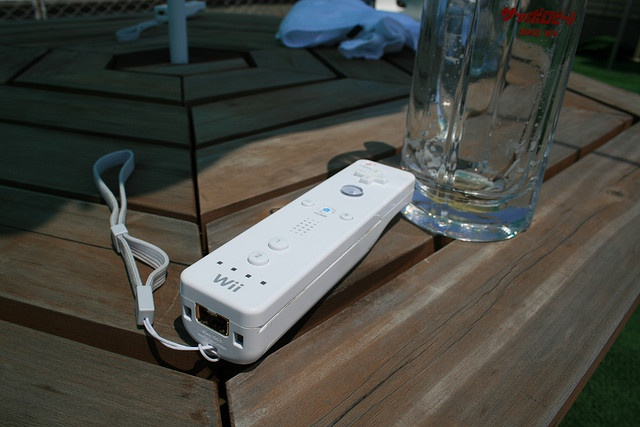Describe the objects in this image and their specific colors. I can see cup in gray, black, and blue tones and remote in gray, lightgray, darkgray, and black tones in this image. 